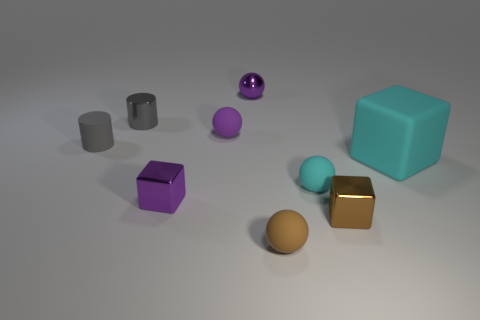Subtract all tiny brown spheres. How many spheres are left? 3 Add 1 big yellow blocks. How many objects exist? 10 Subtract all purple spheres. How many spheres are left? 2 Subtract all yellow cylinders. How many purple spheres are left? 2 Subtract 2 spheres. How many spheres are left? 2 Subtract all cylinders. How many objects are left? 7 Subtract all cyan cubes. Subtract all purple cylinders. How many cubes are left? 2 Subtract all brown things. Subtract all big yellow balls. How many objects are left? 7 Add 4 big cyan things. How many big cyan things are left? 5 Add 2 big objects. How many big objects exist? 3 